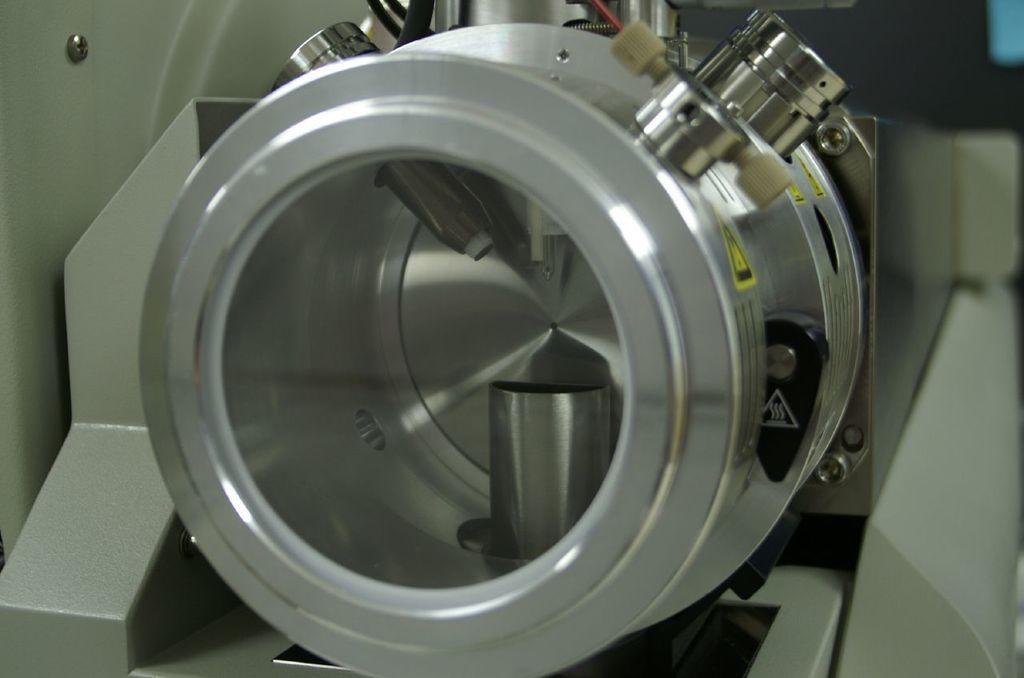In one or two sentences, can you explain what this image depicts? In this image there is an object that looks like a machine. And there are objects in the background. 